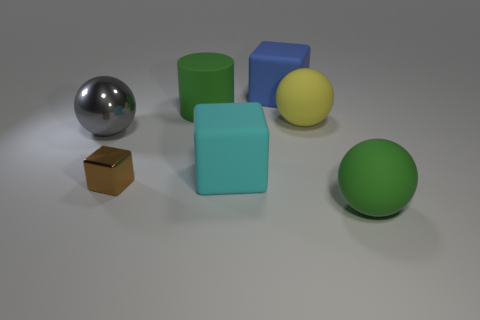Subtract all rubber blocks. How many blocks are left? 1 Add 1 cyan things. How many objects exist? 8 Subtract all cubes. How many objects are left? 4 Subtract all brown spheres. Subtract all green blocks. How many spheres are left? 3 Add 5 large gray balls. How many large gray balls are left? 6 Add 7 green objects. How many green objects exist? 9 Subtract 1 gray spheres. How many objects are left? 6 Subtract all big brown matte objects. Subtract all brown metallic cubes. How many objects are left? 6 